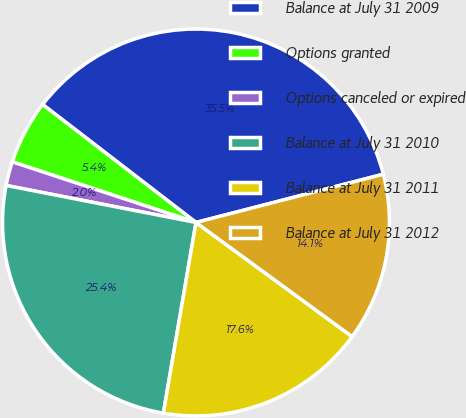Convert chart to OTSL. <chart><loc_0><loc_0><loc_500><loc_500><pie_chart><fcel>Balance at July 31 2009<fcel>Options granted<fcel>Options canceled or expired<fcel>Balance at July 31 2010<fcel>Balance at July 31 2011<fcel>Balance at July 31 2012<nl><fcel>35.55%<fcel>5.36%<fcel>2.01%<fcel>25.37%<fcel>17.65%<fcel>14.06%<nl></chart> 